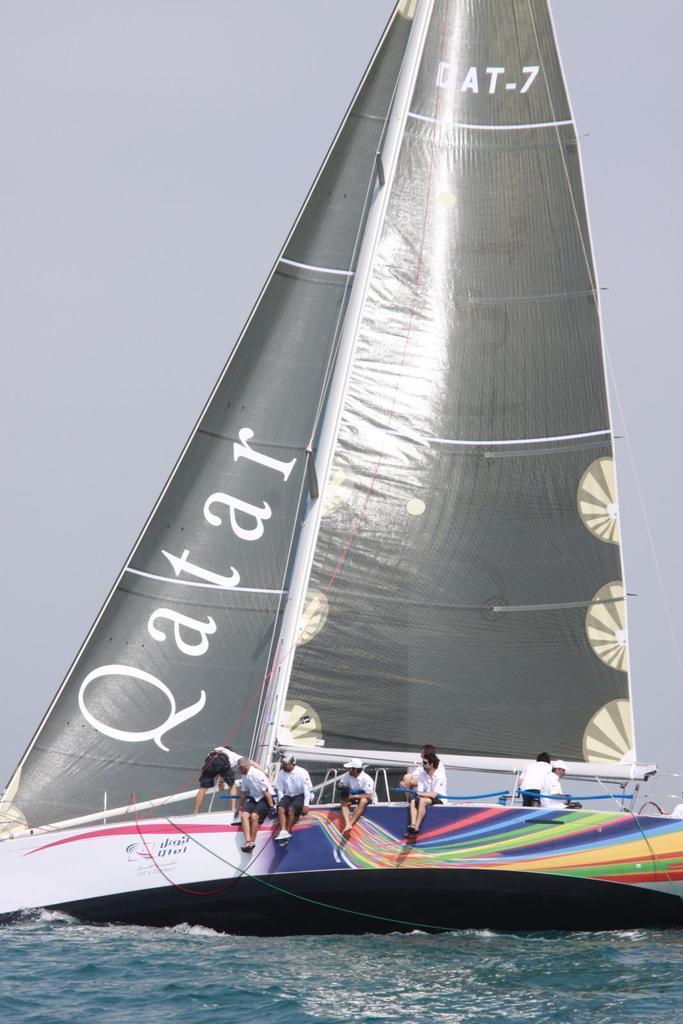In one or two sentences, can you explain what this image depicts? In this picture we can see some people sitting and standing on a boat and the boat is on the water. Behind the boat there is the sky. 